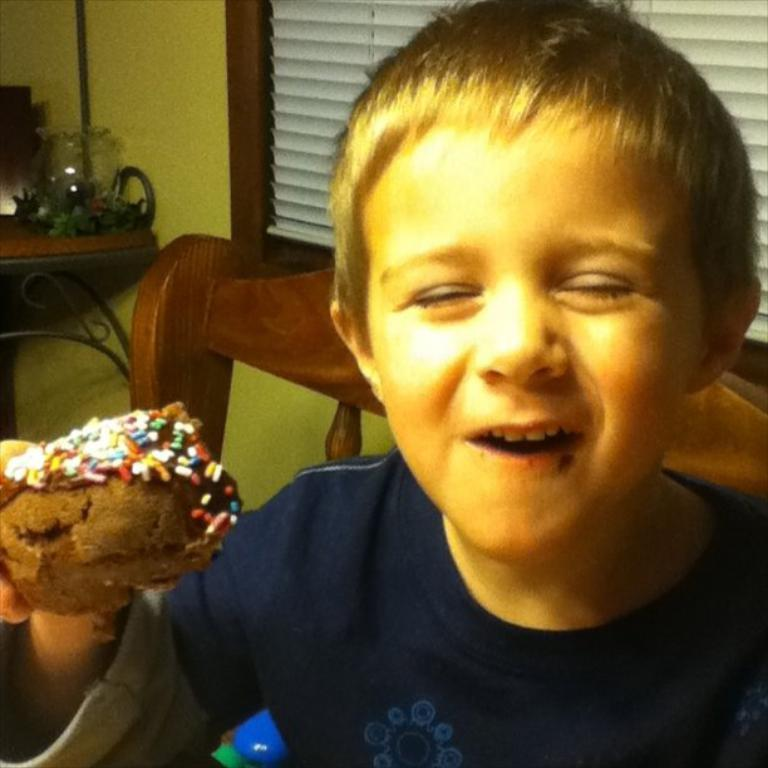Who is the main subject in the image? There is a boy in the image. What is the boy doing in the image? The boy is smiling in the image. What is the boy holding in the image? The boy is holding a cake in the image. What can be seen in the background of the image? There is a chair, a wall, a curtain, and some objects in the background of the image. How many brothers does the boy have in the image? There is no information about the boy's brothers in the image. What activity is the boy's father doing in the image? There is no father or any activity involving a father mentioned in the image. 